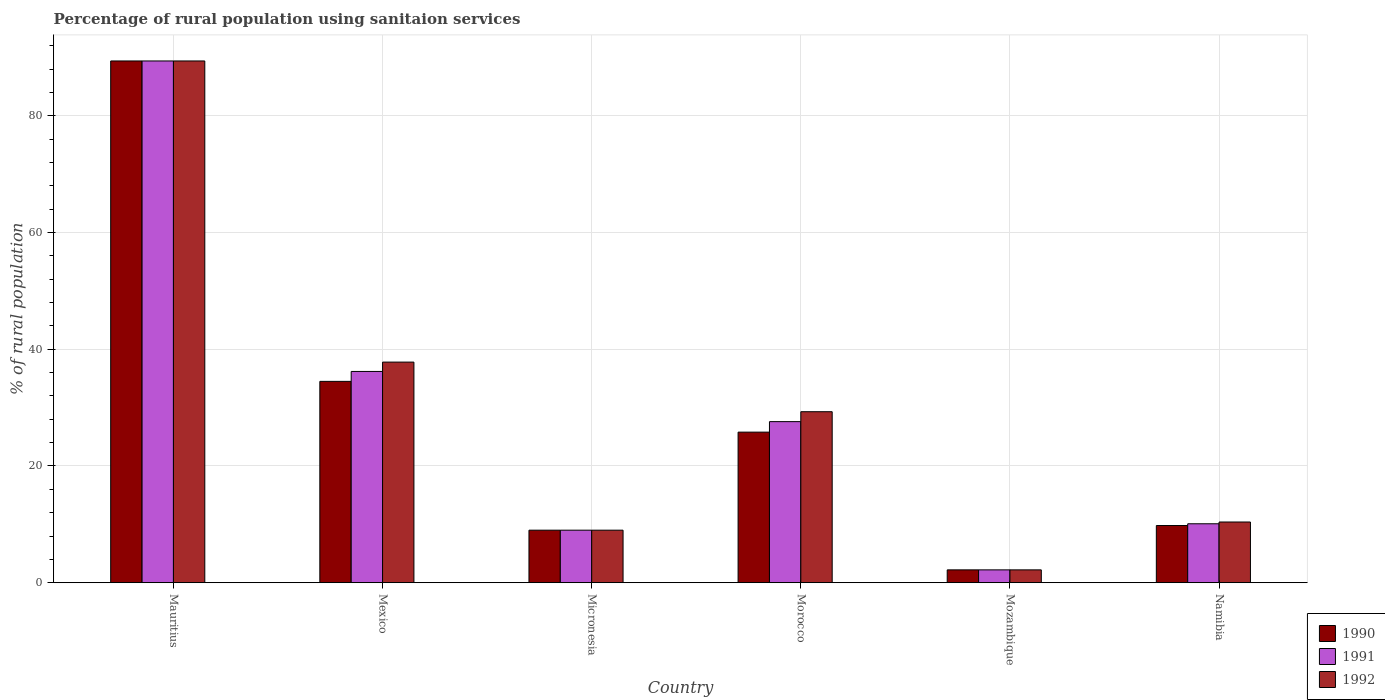How many groups of bars are there?
Provide a short and direct response. 6. How many bars are there on the 5th tick from the left?
Provide a succinct answer. 3. What is the label of the 3rd group of bars from the left?
Provide a short and direct response. Micronesia. In how many cases, is the number of bars for a given country not equal to the number of legend labels?
Make the answer very short. 0. What is the percentage of rural population using sanitaion services in 1990 in Mexico?
Give a very brief answer. 34.5. Across all countries, what is the maximum percentage of rural population using sanitaion services in 1992?
Your answer should be compact. 89.4. Across all countries, what is the minimum percentage of rural population using sanitaion services in 1992?
Offer a very short reply. 2.2. In which country was the percentage of rural population using sanitaion services in 1991 maximum?
Ensure brevity in your answer.  Mauritius. In which country was the percentage of rural population using sanitaion services in 1990 minimum?
Your answer should be compact. Mozambique. What is the total percentage of rural population using sanitaion services in 1990 in the graph?
Keep it short and to the point. 170.7. What is the difference between the percentage of rural population using sanitaion services in 1991 in Micronesia and that in Namibia?
Give a very brief answer. -1.1. What is the difference between the percentage of rural population using sanitaion services in 1991 in Mauritius and the percentage of rural population using sanitaion services in 1992 in Mozambique?
Your response must be concise. 87.2. What is the average percentage of rural population using sanitaion services in 1992 per country?
Your answer should be very brief. 29.68. What is the difference between the percentage of rural population using sanitaion services of/in 1990 and percentage of rural population using sanitaion services of/in 1991 in Mexico?
Provide a succinct answer. -1.7. What is the ratio of the percentage of rural population using sanitaion services in 1991 in Mexico to that in Morocco?
Make the answer very short. 1.31. Is the percentage of rural population using sanitaion services in 1992 in Mexico less than that in Mozambique?
Your response must be concise. No. What is the difference between the highest and the second highest percentage of rural population using sanitaion services in 1991?
Provide a short and direct response. 61.8. What is the difference between the highest and the lowest percentage of rural population using sanitaion services in 1991?
Your answer should be very brief. 87.2. In how many countries, is the percentage of rural population using sanitaion services in 1990 greater than the average percentage of rural population using sanitaion services in 1990 taken over all countries?
Provide a short and direct response. 2. What does the 2nd bar from the right in Namibia represents?
Give a very brief answer. 1991. Are all the bars in the graph horizontal?
Make the answer very short. No. Are the values on the major ticks of Y-axis written in scientific E-notation?
Your response must be concise. No. Does the graph contain any zero values?
Give a very brief answer. No. Where does the legend appear in the graph?
Keep it short and to the point. Bottom right. How are the legend labels stacked?
Provide a succinct answer. Vertical. What is the title of the graph?
Provide a short and direct response. Percentage of rural population using sanitaion services. What is the label or title of the Y-axis?
Give a very brief answer. % of rural population. What is the % of rural population of 1990 in Mauritius?
Give a very brief answer. 89.4. What is the % of rural population of 1991 in Mauritius?
Give a very brief answer. 89.4. What is the % of rural population of 1992 in Mauritius?
Offer a terse response. 89.4. What is the % of rural population of 1990 in Mexico?
Your response must be concise. 34.5. What is the % of rural population of 1991 in Mexico?
Your answer should be very brief. 36.2. What is the % of rural population of 1992 in Mexico?
Offer a very short reply. 37.8. What is the % of rural population in 1992 in Micronesia?
Your response must be concise. 9. What is the % of rural population of 1990 in Morocco?
Offer a very short reply. 25.8. What is the % of rural population in 1991 in Morocco?
Offer a very short reply. 27.6. What is the % of rural population in 1992 in Morocco?
Offer a very short reply. 29.3. What is the % of rural population of 1990 in Mozambique?
Provide a short and direct response. 2.2. Across all countries, what is the maximum % of rural population of 1990?
Your answer should be compact. 89.4. Across all countries, what is the maximum % of rural population of 1991?
Give a very brief answer. 89.4. Across all countries, what is the maximum % of rural population in 1992?
Keep it short and to the point. 89.4. Across all countries, what is the minimum % of rural population of 1990?
Your answer should be compact. 2.2. Across all countries, what is the minimum % of rural population in 1991?
Ensure brevity in your answer.  2.2. What is the total % of rural population in 1990 in the graph?
Give a very brief answer. 170.7. What is the total % of rural population in 1991 in the graph?
Your response must be concise. 174.5. What is the total % of rural population in 1992 in the graph?
Provide a short and direct response. 178.1. What is the difference between the % of rural population in 1990 in Mauritius and that in Mexico?
Your answer should be very brief. 54.9. What is the difference between the % of rural population of 1991 in Mauritius and that in Mexico?
Your answer should be very brief. 53.2. What is the difference between the % of rural population in 1992 in Mauritius and that in Mexico?
Your response must be concise. 51.6. What is the difference between the % of rural population of 1990 in Mauritius and that in Micronesia?
Provide a succinct answer. 80.4. What is the difference between the % of rural population of 1991 in Mauritius and that in Micronesia?
Give a very brief answer. 80.4. What is the difference between the % of rural population of 1992 in Mauritius and that in Micronesia?
Give a very brief answer. 80.4. What is the difference between the % of rural population in 1990 in Mauritius and that in Morocco?
Your answer should be compact. 63.6. What is the difference between the % of rural population in 1991 in Mauritius and that in Morocco?
Your response must be concise. 61.8. What is the difference between the % of rural population in 1992 in Mauritius and that in Morocco?
Give a very brief answer. 60.1. What is the difference between the % of rural population in 1990 in Mauritius and that in Mozambique?
Provide a short and direct response. 87.2. What is the difference between the % of rural population in 1991 in Mauritius and that in Mozambique?
Make the answer very short. 87.2. What is the difference between the % of rural population in 1992 in Mauritius and that in Mozambique?
Your answer should be very brief. 87.2. What is the difference between the % of rural population in 1990 in Mauritius and that in Namibia?
Offer a terse response. 79.6. What is the difference between the % of rural population in 1991 in Mauritius and that in Namibia?
Your response must be concise. 79.3. What is the difference between the % of rural population of 1992 in Mauritius and that in Namibia?
Your answer should be compact. 79. What is the difference between the % of rural population of 1990 in Mexico and that in Micronesia?
Ensure brevity in your answer.  25.5. What is the difference between the % of rural population in 1991 in Mexico and that in Micronesia?
Your response must be concise. 27.2. What is the difference between the % of rural population of 1992 in Mexico and that in Micronesia?
Ensure brevity in your answer.  28.8. What is the difference between the % of rural population in 1990 in Mexico and that in Morocco?
Offer a terse response. 8.7. What is the difference between the % of rural population of 1992 in Mexico and that in Morocco?
Provide a succinct answer. 8.5. What is the difference between the % of rural population of 1990 in Mexico and that in Mozambique?
Provide a succinct answer. 32.3. What is the difference between the % of rural population in 1991 in Mexico and that in Mozambique?
Ensure brevity in your answer.  34. What is the difference between the % of rural population of 1992 in Mexico and that in Mozambique?
Provide a short and direct response. 35.6. What is the difference between the % of rural population of 1990 in Mexico and that in Namibia?
Provide a short and direct response. 24.7. What is the difference between the % of rural population in 1991 in Mexico and that in Namibia?
Give a very brief answer. 26.1. What is the difference between the % of rural population in 1992 in Mexico and that in Namibia?
Your answer should be compact. 27.4. What is the difference between the % of rural population of 1990 in Micronesia and that in Morocco?
Provide a short and direct response. -16.8. What is the difference between the % of rural population of 1991 in Micronesia and that in Morocco?
Your answer should be very brief. -18.6. What is the difference between the % of rural population of 1992 in Micronesia and that in Morocco?
Offer a very short reply. -20.3. What is the difference between the % of rural population in 1990 in Micronesia and that in Mozambique?
Your response must be concise. 6.8. What is the difference between the % of rural population in 1991 in Micronesia and that in Mozambique?
Offer a very short reply. 6.8. What is the difference between the % of rural population in 1991 in Micronesia and that in Namibia?
Your response must be concise. -1.1. What is the difference between the % of rural population of 1992 in Micronesia and that in Namibia?
Ensure brevity in your answer.  -1.4. What is the difference between the % of rural population in 1990 in Morocco and that in Mozambique?
Offer a terse response. 23.6. What is the difference between the % of rural population of 1991 in Morocco and that in Mozambique?
Make the answer very short. 25.4. What is the difference between the % of rural population in 1992 in Morocco and that in Mozambique?
Your answer should be very brief. 27.1. What is the difference between the % of rural population in 1990 in Morocco and that in Namibia?
Offer a very short reply. 16. What is the difference between the % of rural population in 1992 in Morocco and that in Namibia?
Give a very brief answer. 18.9. What is the difference between the % of rural population in 1990 in Mozambique and that in Namibia?
Offer a terse response. -7.6. What is the difference between the % of rural population in 1990 in Mauritius and the % of rural population in 1991 in Mexico?
Your response must be concise. 53.2. What is the difference between the % of rural population of 1990 in Mauritius and the % of rural population of 1992 in Mexico?
Offer a terse response. 51.6. What is the difference between the % of rural population in 1991 in Mauritius and the % of rural population in 1992 in Mexico?
Give a very brief answer. 51.6. What is the difference between the % of rural population of 1990 in Mauritius and the % of rural population of 1991 in Micronesia?
Your answer should be compact. 80.4. What is the difference between the % of rural population of 1990 in Mauritius and the % of rural population of 1992 in Micronesia?
Make the answer very short. 80.4. What is the difference between the % of rural population of 1991 in Mauritius and the % of rural population of 1992 in Micronesia?
Give a very brief answer. 80.4. What is the difference between the % of rural population of 1990 in Mauritius and the % of rural population of 1991 in Morocco?
Make the answer very short. 61.8. What is the difference between the % of rural population of 1990 in Mauritius and the % of rural population of 1992 in Morocco?
Ensure brevity in your answer.  60.1. What is the difference between the % of rural population in 1991 in Mauritius and the % of rural population in 1992 in Morocco?
Your answer should be compact. 60.1. What is the difference between the % of rural population in 1990 in Mauritius and the % of rural population in 1991 in Mozambique?
Provide a succinct answer. 87.2. What is the difference between the % of rural population of 1990 in Mauritius and the % of rural population of 1992 in Mozambique?
Your answer should be compact. 87.2. What is the difference between the % of rural population in 1991 in Mauritius and the % of rural population in 1992 in Mozambique?
Offer a very short reply. 87.2. What is the difference between the % of rural population in 1990 in Mauritius and the % of rural population in 1991 in Namibia?
Provide a short and direct response. 79.3. What is the difference between the % of rural population of 1990 in Mauritius and the % of rural population of 1992 in Namibia?
Ensure brevity in your answer.  79. What is the difference between the % of rural population in 1991 in Mauritius and the % of rural population in 1992 in Namibia?
Make the answer very short. 79. What is the difference between the % of rural population of 1990 in Mexico and the % of rural population of 1992 in Micronesia?
Your answer should be very brief. 25.5. What is the difference between the % of rural population of 1991 in Mexico and the % of rural population of 1992 in Micronesia?
Make the answer very short. 27.2. What is the difference between the % of rural population in 1990 in Mexico and the % of rural population in 1991 in Morocco?
Offer a very short reply. 6.9. What is the difference between the % of rural population of 1990 in Mexico and the % of rural population of 1991 in Mozambique?
Provide a short and direct response. 32.3. What is the difference between the % of rural population in 1990 in Mexico and the % of rural population in 1992 in Mozambique?
Provide a succinct answer. 32.3. What is the difference between the % of rural population in 1990 in Mexico and the % of rural population in 1991 in Namibia?
Offer a terse response. 24.4. What is the difference between the % of rural population in 1990 in Mexico and the % of rural population in 1992 in Namibia?
Your answer should be compact. 24.1. What is the difference between the % of rural population of 1991 in Mexico and the % of rural population of 1992 in Namibia?
Your answer should be very brief. 25.8. What is the difference between the % of rural population of 1990 in Micronesia and the % of rural population of 1991 in Morocco?
Provide a succinct answer. -18.6. What is the difference between the % of rural population in 1990 in Micronesia and the % of rural population in 1992 in Morocco?
Provide a succinct answer. -20.3. What is the difference between the % of rural population of 1991 in Micronesia and the % of rural population of 1992 in Morocco?
Provide a short and direct response. -20.3. What is the difference between the % of rural population in 1990 in Micronesia and the % of rural population in 1991 in Mozambique?
Keep it short and to the point. 6.8. What is the difference between the % of rural population in 1990 in Micronesia and the % of rural population in 1992 in Mozambique?
Provide a succinct answer. 6.8. What is the difference between the % of rural population in 1991 in Micronesia and the % of rural population in 1992 in Mozambique?
Make the answer very short. 6.8. What is the difference between the % of rural population in 1990 in Micronesia and the % of rural population in 1991 in Namibia?
Give a very brief answer. -1.1. What is the difference between the % of rural population in 1991 in Micronesia and the % of rural population in 1992 in Namibia?
Provide a short and direct response. -1.4. What is the difference between the % of rural population of 1990 in Morocco and the % of rural population of 1991 in Mozambique?
Provide a short and direct response. 23.6. What is the difference between the % of rural population in 1990 in Morocco and the % of rural population in 1992 in Mozambique?
Offer a very short reply. 23.6. What is the difference between the % of rural population in 1991 in Morocco and the % of rural population in 1992 in Mozambique?
Keep it short and to the point. 25.4. What is the difference between the % of rural population of 1990 in Morocco and the % of rural population of 1992 in Namibia?
Offer a very short reply. 15.4. What is the difference between the % of rural population of 1991 in Morocco and the % of rural population of 1992 in Namibia?
Make the answer very short. 17.2. What is the difference between the % of rural population in 1991 in Mozambique and the % of rural population in 1992 in Namibia?
Your answer should be compact. -8.2. What is the average % of rural population of 1990 per country?
Ensure brevity in your answer.  28.45. What is the average % of rural population in 1991 per country?
Provide a short and direct response. 29.08. What is the average % of rural population of 1992 per country?
Ensure brevity in your answer.  29.68. What is the difference between the % of rural population of 1990 and % of rural population of 1992 in Mauritius?
Provide a succinct answer. 0. What is the difference between the % of rural population of 1990 and % of rural population of 1992 in Mexico?
Your response must be concise. -3.3. What is the difference between the % of rural population of 1991 and % of rural population of 1992 in Mexico?
Your answer should be compact. -1.6. What is the difference between the % of rural population in 1990 and % of rural population in 1991 in Micronesia?
Ensure brevity in your answer.  0. What is the difference between the % of rural population of 1990 and % of rural population of 1992 in Micronesia?
Ensure brevity in your answer.  0. What is the difference between the % of rural population in 1990 and % of rural population in 1991 in Morocco?
Ensure brevity in your answer.  -1.8. What is the difference between the % of rural population in 1990 and % of rural population in 1992 in Morocco?
Give a very brief answer. -3.5. What is the difference between the % of rural population of 1991 and % of rural population of 1992 in Morocco?
Your answer should be very brief. -1.7. What is the difference between the % of rural population in 1991 and % of rural population in 1992 in Mozambique?
Ensure brevity in your answer.  0. What is the difference between the % of rural population of 1990 and % of rural population of 1991 in Namibia?
Make the answer very short. -0.3. What is the difference between the % of rural population in 1990 and % of rural population in 1992 in Namibia?
Your answer should be very brief. -0.6. What is the difference between the % of rural population of 1991 and % of rural population of 1992 in Namibia?
Give a very brief answer. -0.3. What is the ratio of the % of rural population of 1990 in Mauritius to that in Mexico?
Provide a short and direct response. 2.59. What is the ratio of the % of rural population of 1991 in Mauritius to that in Mexico?
Give a very brief answer. 2.47. What is the ratio of the % of rural population in 1992 in Mauritius to that in Mexico?
Offer a terse response. 2.37. What is the ratio of the % of rural population in 1990 in Mauritius to that in Micronesia?
Your answer should be compact. 9.93. What is the ratio of the % of rural population in 1991 in Mauritius to that in Micronesia?
Your response must be concise. 9.93. What is the ratio of the % of rural population in 1992 in Mauritius to that in Micronesia?
Provide a succinct answer. 9.93. What is the ratio of the % of rural population in 1990 in Mauritius to that in Morocco?
Make the answer very short. 3.47. What is the ratio of the % of rural population in 1991 in Mauritius to that in Morocco?
Offer a terse response. 3.24. What is the ratio of the % of rural population of 1992 in Mauritius to that in Morocco?
Your answer should be compact. 3.05. What is the ratio of the % of rural population in 1990 in Mauritius to that in Mozambique?
Your response must be concise. 40.64. What is the ratio of the % of rural population of 1991 in Mauritius to that in Mozambique?
Offer a terse response. 40.64. What is the ratio of the % of rural population in 1992 in Mauritius to that in Mozambique?
Offer a terse response. 40.64. What is the ratio of the % of rural population of 1990 in Mauritius to that in Namibia?
Provide a succinct answer. 9.12. What is the ratio of the % of rural population in 1991 in Mauritius to that in Namibia?
Keep it short and to the point. 8.85. What is the ratio of the % of rural population in 1992 in Mauritius to that in Namibia?
Ensure brevity in your answer.  8.6. What is the ratio of the % of rural population in 1990 in Mexico to that in Micronesia?
Ensure brevity in your answer.  3.83. What is the ratio of the % of rural population in 1991 in Mexico to that in Micronesia?
Offer a very short reply. 4.02. What is the ratio of the % of rural population of 1990 in Mexico to that in Morocco?
Keep it short and to the point. 1.34. What is the ratio of the % of rural population of 1991 in Mexico to that in Morocco?
Keep it short and to the point. 1.31. What is the ratio of the % of rural population of 1992 in Mexico to that in Morocco?
Provide a short and direct response. 1.29. What is the ratio of the % of rural population of 1990 in Mexico to that in Mozambique?
Offer a terse response. 15.68. What is the ratio of the % of rural population in 1991 in Mexico to that in Mozambique?
Offer a terse response. 16.45. What is the ratio of the % of rural population in 1992 in Mexico to that in Mozambique?
Your response must be concise. 17.18. What is the ratio of the % of rural population of 1990 in Mexico to that in Namibia?
Your response must be concise. 3.52. What is the ratio of the % of rural population of 1991 in Mexico to that in Namibia?
Offer a very short reply. 3.58. What is the ratio of the % of rural population in 1992 in Mexico to that in Namibia?
Your answer should be very brief. 3.63. What is the ratio of the % of rural population in 1990 in Micronesia to that in Morocco?
Give a very brief answer. 0.35. What is the ratio of the % of rural population in 1991 in Micronesia to that in Morocco?
Provide a succinct answer. 0.33. What is the ratio of the % of rural population in 1992 in Micronesia to that in Morocco?
Give a very brief answer. 0.31. What is the ratio of the % of rural population in 1990 in Micronesia to that in Mozambique?
Make the answer very short. 4.09. What is the ratio of the % of rural population in 1991 in Micronesia to that in Mozambique?
Your response must be concise. 4.09. What is the ratio of the % of rural population of 1992 in Micronesia to that in Mozambique?
Your response must be concise. 4.09. What is the ratio of the % of rural population of 1990 in Micronesia to that in Namibia?
Your response must be concise. 0.92. What is the ratio of the % of rural population in 1991 in Micronesia to that in Namibia?
Ensure brevity in your answer.  0.89. What is the ratio of the % of rural population of 1992 in Micronesia to that in Namibia?
Provide a short and direct response. 0.87. What is the ratio of the % of rural population in 1990 in Morocco to that in Mozambique?
Make the answer very short. 11.73. What is the ratio of the % of rural population in 1991 in Morocco to that in Mozambique?
Make the answer very short. 12.55. What is the ratio of the % of rural population of 1992 in Morocco to that in Mozambique?
Ensure brevity in your answer.  13.32. What is the ratio of the % of rural population of 1990 in Morocco to that in Namibia?
Ensure brevity in your answer.  2.63. What is the ratio of the % of rural population in 1991 in Morocco to that in Namibia?
Your response must be concise. 2.73. What is the ratio of the % of rural population of 1992 in Morocco to that in Namibia?
Your response must be concise. 2.82. What is the ratio of the % of rural population of 1990 in Mozambique to that in Namibia?
Offer a very short reply. 0.22. What is the ratio of the % of rural population of 1991 in Mozambique to that in Namibia?
Give a very brief answer. 0.22. What is the ratio of the % of rural population in 1992 in Mozambique to that in Namibia?
Offer a terse response. 0.21. What is the difference between the highest and the second highest % of rural population in 1990?
Your answer should be very brief. 54.9. What is the difference between the highest and the second highest % of rural population of 1991?
Offer a very short reply. 53.2. What is the difference between the highest and the second highest % of rural population in 1992?
Your answer should be compact. 51.6. What is the difference between the highest and the lowest % of rural population in 1990?
Provide a succinct answer. 87.2. What is the difference between the highest and the lowest % of rural population of 1991?
Give a very brief answer. 87.2. What is the difference between the highest and the lowest % of rural population in 1992?
Your response must be concise. 87.2. 